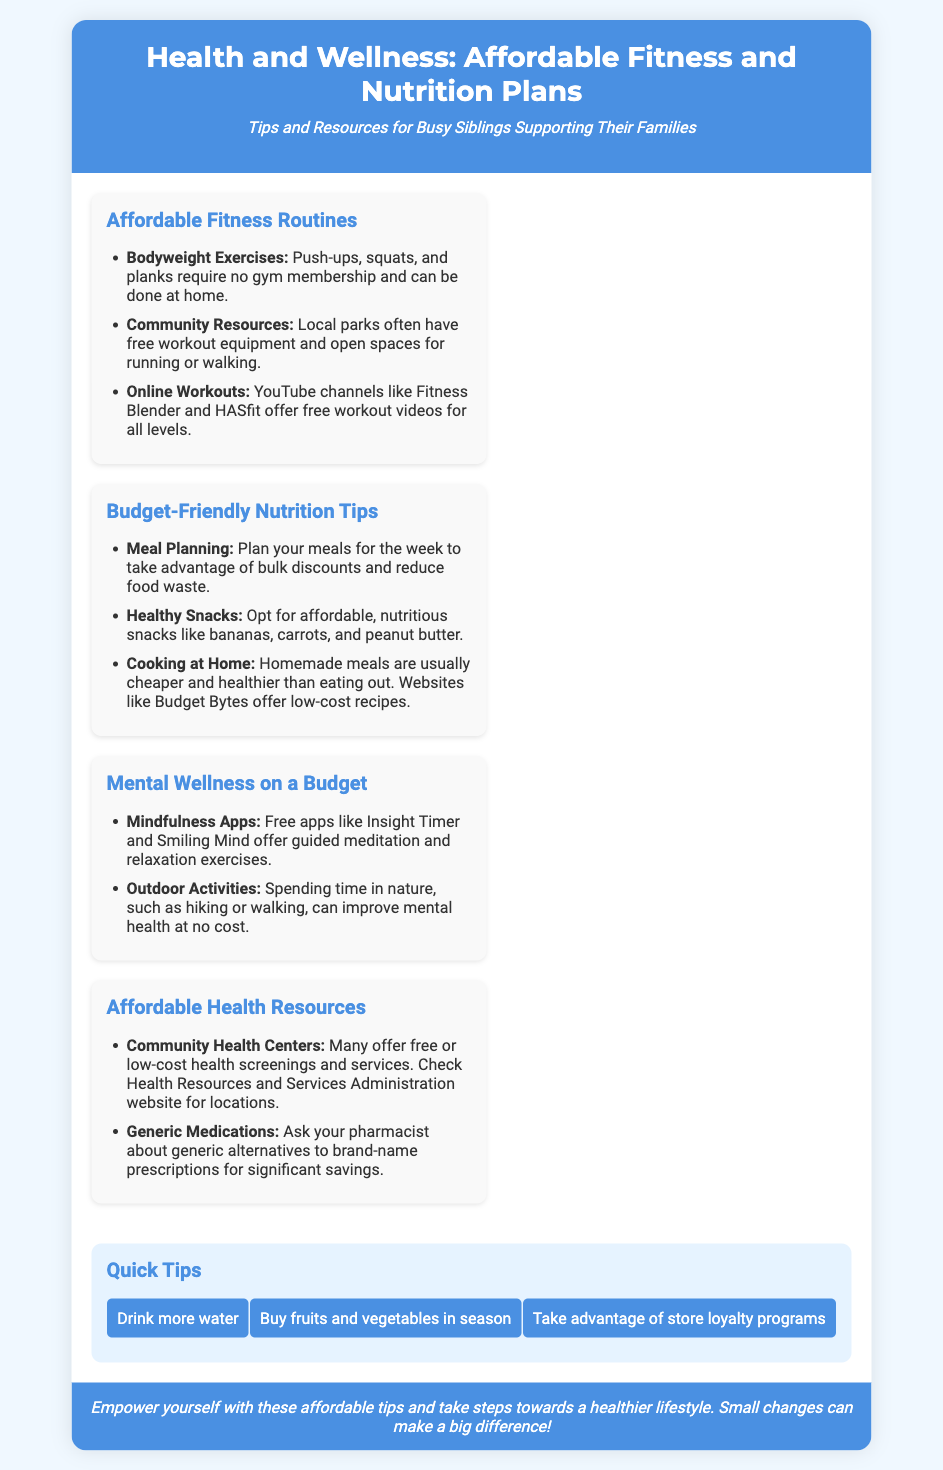What is the title of the poster? The title of the poster is stated at the top and specifies the main focus of the document.
Answer: Health and Wellness: Affordable Fitness and Nutrition Plans How many sections are in the content? The document includes a total of four distinct sections that provide different information.
Answer: Four What are two types of free resources mentioned for fitness? The poster provides specific examples of fitness resources that are available at no cost.
Answer: Bodyweight Exercises, Community Resources Which app is suggested for mindfulness? The poster lists specific apps for mental wellness, focusing on those that are free.
Answer: Insight Timer What is one tip for budget-friendly nutrition? The poster offers practical advice under nutrition tips that can help manage food expenses effectively.
Answer: Meal Planning What color represents the header and footer of the poster? The colors for the header and footer are consistent, creating a unified look throughout the document.
Answer: Blue Which two websites are mentioned for healthy recipes and workouts? The document refers to websites that help with cooking and fitness related to budget-friendly options.
Answer: Budget Bytes, Fitness Blender What is encouraged to drink more of in the quick tips? The quick tips section provides a straightforward health suggestion common in wellness advice.
Answer: Water Which section discusses outdoor activities for mental wellness? The poster categorizes content into various sections, one specifically addressing mental wellness strategies.
Answer: Mental Wellness on a Budget 